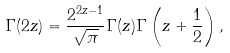Convert formula to latex. <formula><loc_0><loc_0><loc_500><loc_500>\Gamma ( 2 z ) = \frac { 2 ^ { 2 z - 1 } } { \sqrt { \pi } } \Gamma ( z ) \Gamma \left ( z + \frac { 1 } { 2 } \right ) ,</formula> 